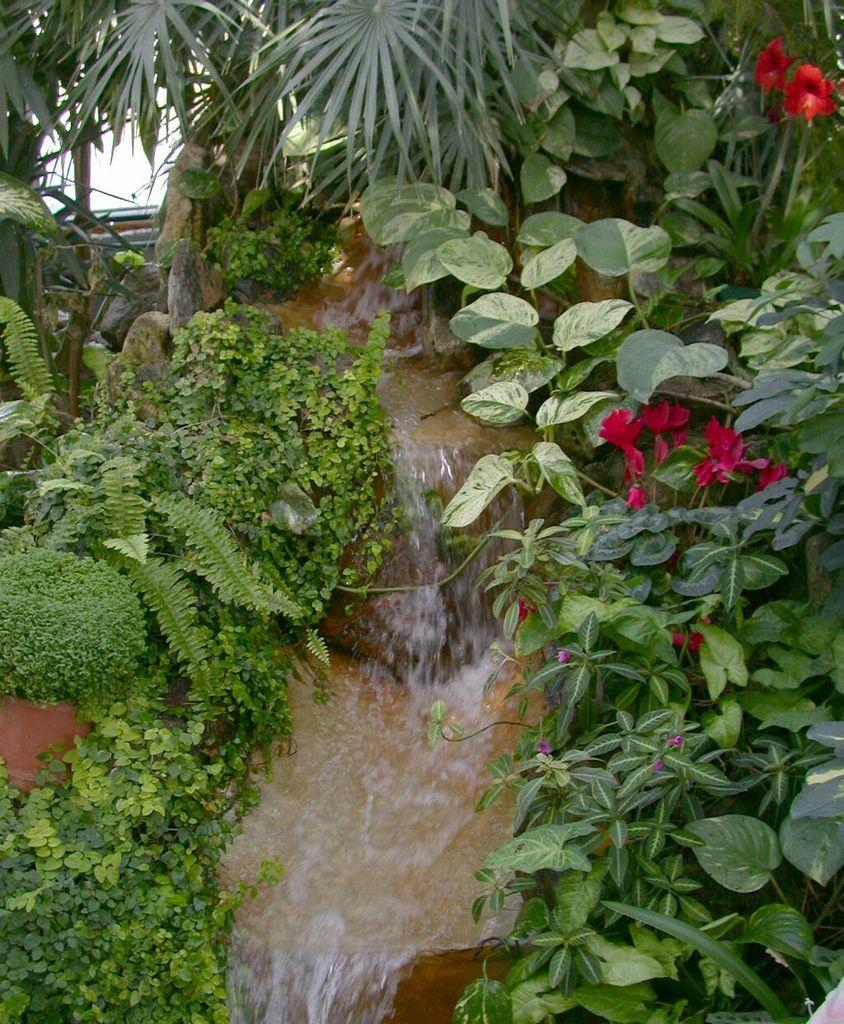What type of living organisms can be seen in the image? Plants are visible in the image. What colors are the flowers in the image? The flowers in the image are red and pink. What else can be seen in the image besides plants and flowers? Water is visible in the image. Can you see a deer fighting with another animal in the image? No, there is no deer or any fighting animals present in the image. The image only features plants, flowers, and water. 